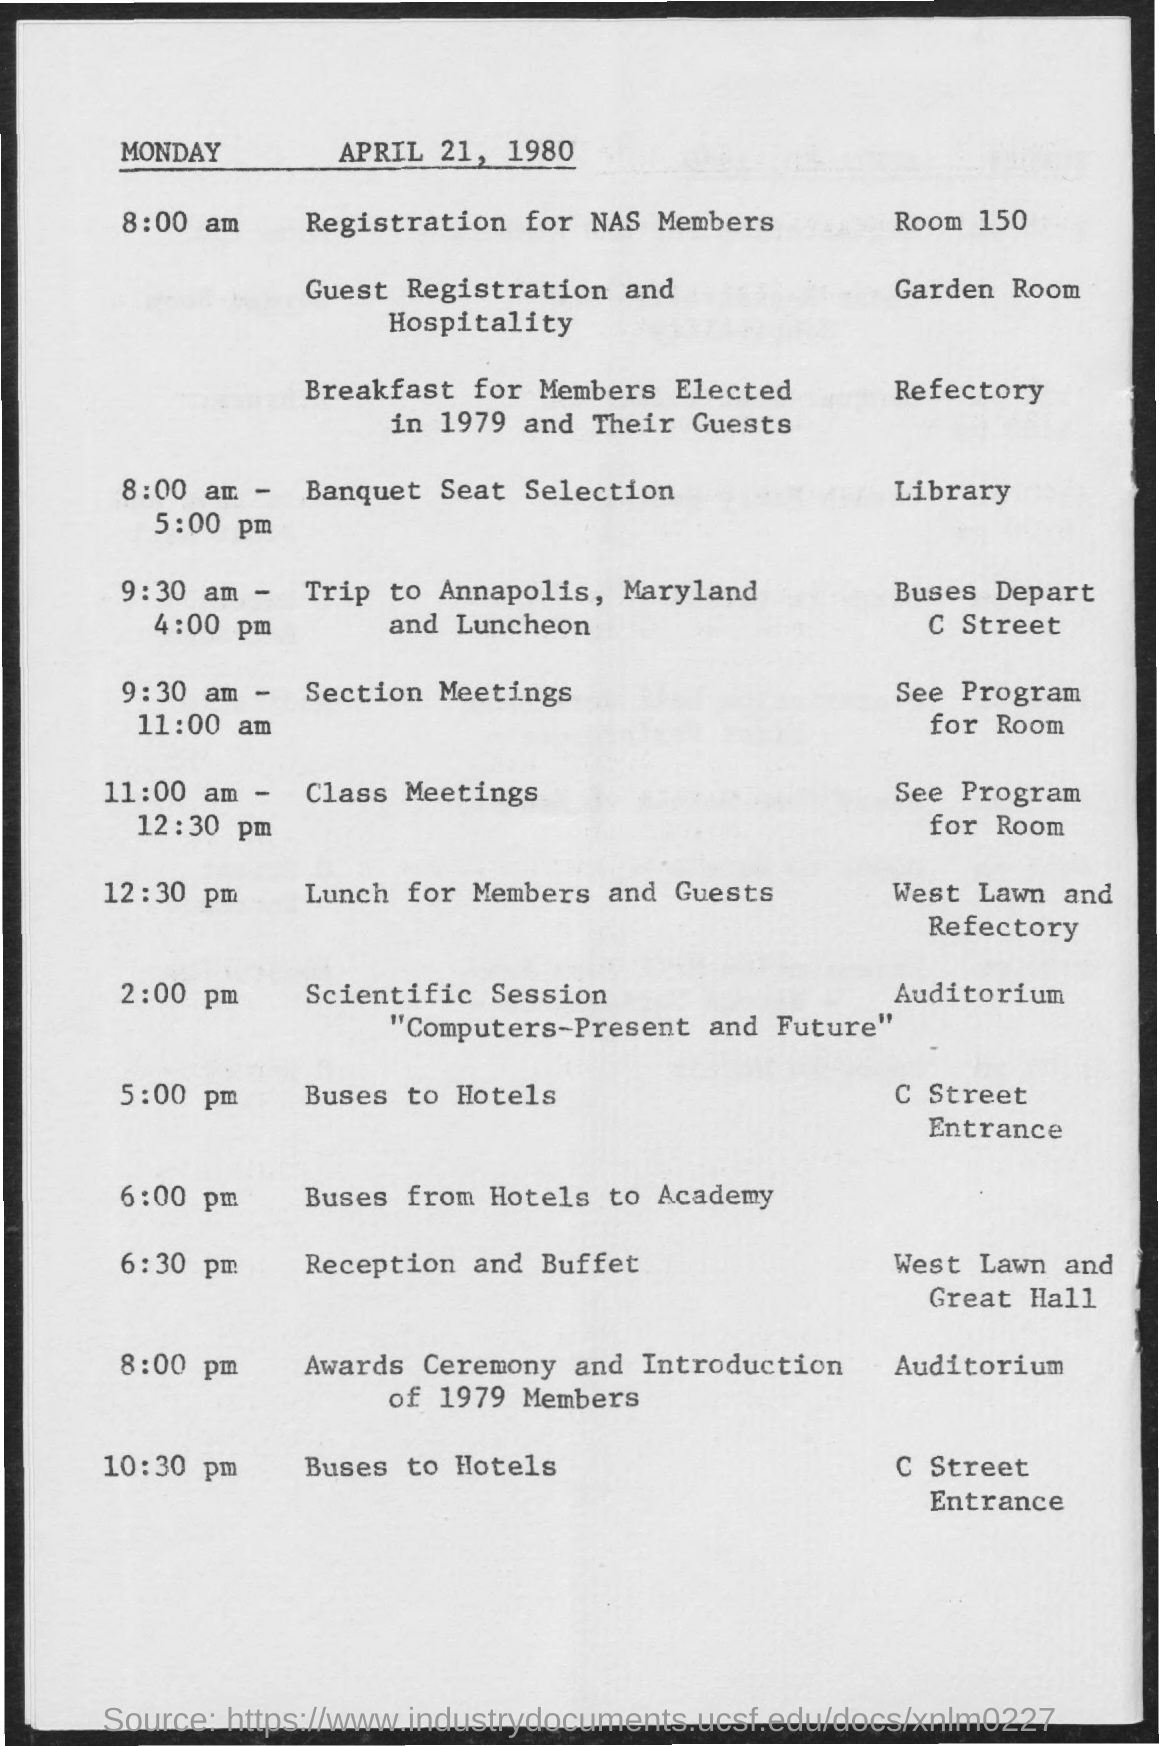Draw attention to some important aspects in this diagram. The date mentioned in the given page is April 21, 1980, which is a Monday. The awards ceremony and introduction of 1979 members took place at the auditorium. The registration room number for NAS members is 150. The garden room is designated for guest registration and hospitality purposes. The itinerary for the trip to Annapolis, Maryland includes a lunch period from 9:30 am to 4:00 pm. 